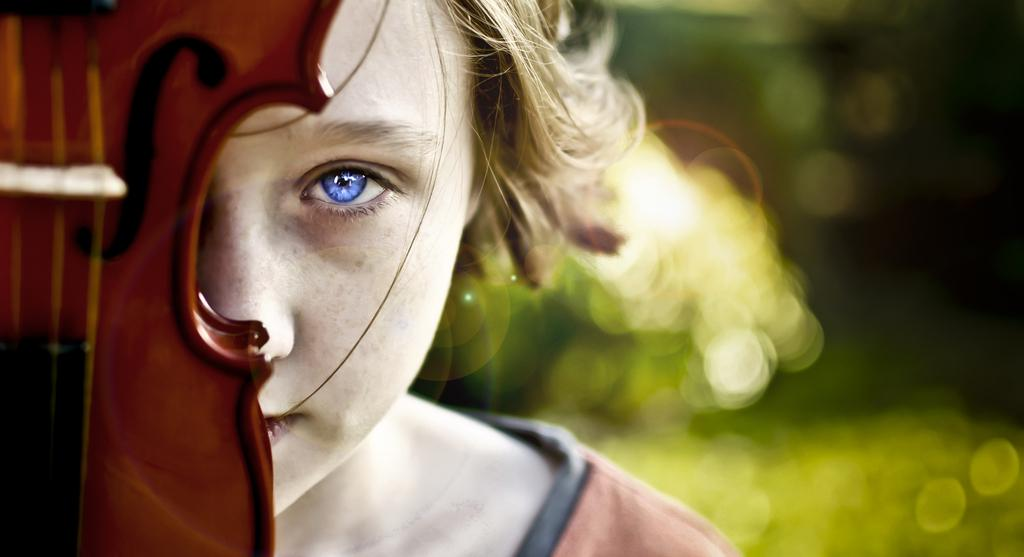What is the main subject of the image? There is a person in the image. What object can be seen with the person? There is a musical instrument in the image. What holiday is being celebrated in the image? There is no indication of a holiday being celebrated in the image. What season is depicted in the image? The provided facts do not mention any seasonal details, so it cannot be determined from the image. 